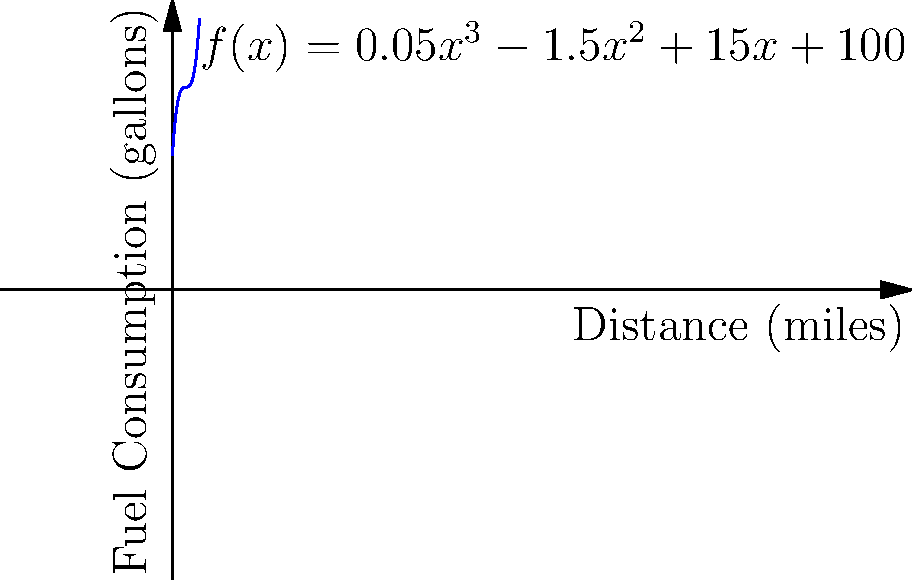As a logistics manager at YRC Worldwide Inc., you're tasked with optimizing fuel consumption for a new truck route. The fuel consumption (in gallons) is modeled by the function $f(x) = 0.05x^3 - 1.5x^2 + 15x + 100$, where $x$ is the distance traveled in miles. At what distance does the truck consume the least amount of fuel? To find the distance where fuel consumption is minimized:

1) The minimum point occurs where the derivative of the function equals zero.

2) Calculate the derivative:
   $f'(x) = 0.15x^2 - 3x + 15$

3) Set the derivative to zero and solve:
   $0.15x^2 - 3x + 15 = 0$

4) This is a quadratic equation. Use the quadratic formula:
   $x = \frac{-b \pm \sqrt{b^2 - 4ac}}{2a}$

   Where $a = 0.15$, $b = -3$, and $c = 15$

5) Solving:
   $x = \frac{3 \pm \sqrt{9 - 9}}{0.3} = \frac{3 \pm 0}{0.3} = 10$

6) The second derivative $f''(x) = 0.3x - 3$ is positive when $x > 10$, confirming this is a minimum.

Therefore, the fuel consumption is minimized at a distance of 10 miles.
Answer: 10 miles 